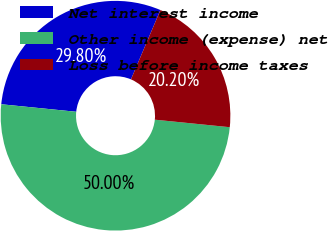Convert chart to OTSL. <chart><loc_0><loc_0><loc_500><loc_500><pie_chart><fcel>Net interest income<fcel>Other income (expense) net<fcel>Loss before income taxes<nl><fcel>29.8%<fcel>50.0%<fcel>20.2%<nl></chart> 